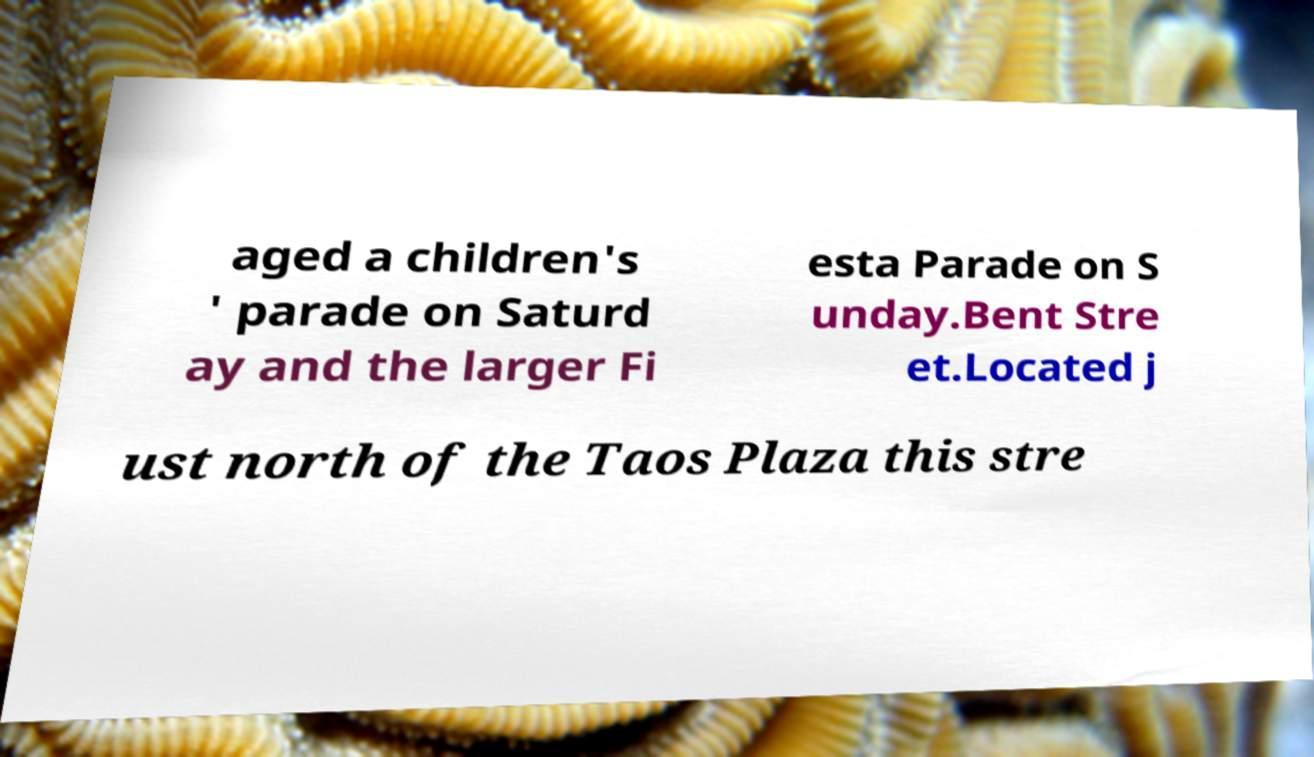Could you assist in decoding the text presented in this image and type it out clearly? aged a children's ' parade on Saturd ay and the larger Fi esta Parade on S unday.Bent Stre et.Located j ust north of the Taos Plaza this stre 